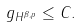Convert formula to latex. <formula><loc_0><loc_0><loc_500><loc_500>\| g \| _ { H ^ { \beta , p } } \leq C .</formula> 